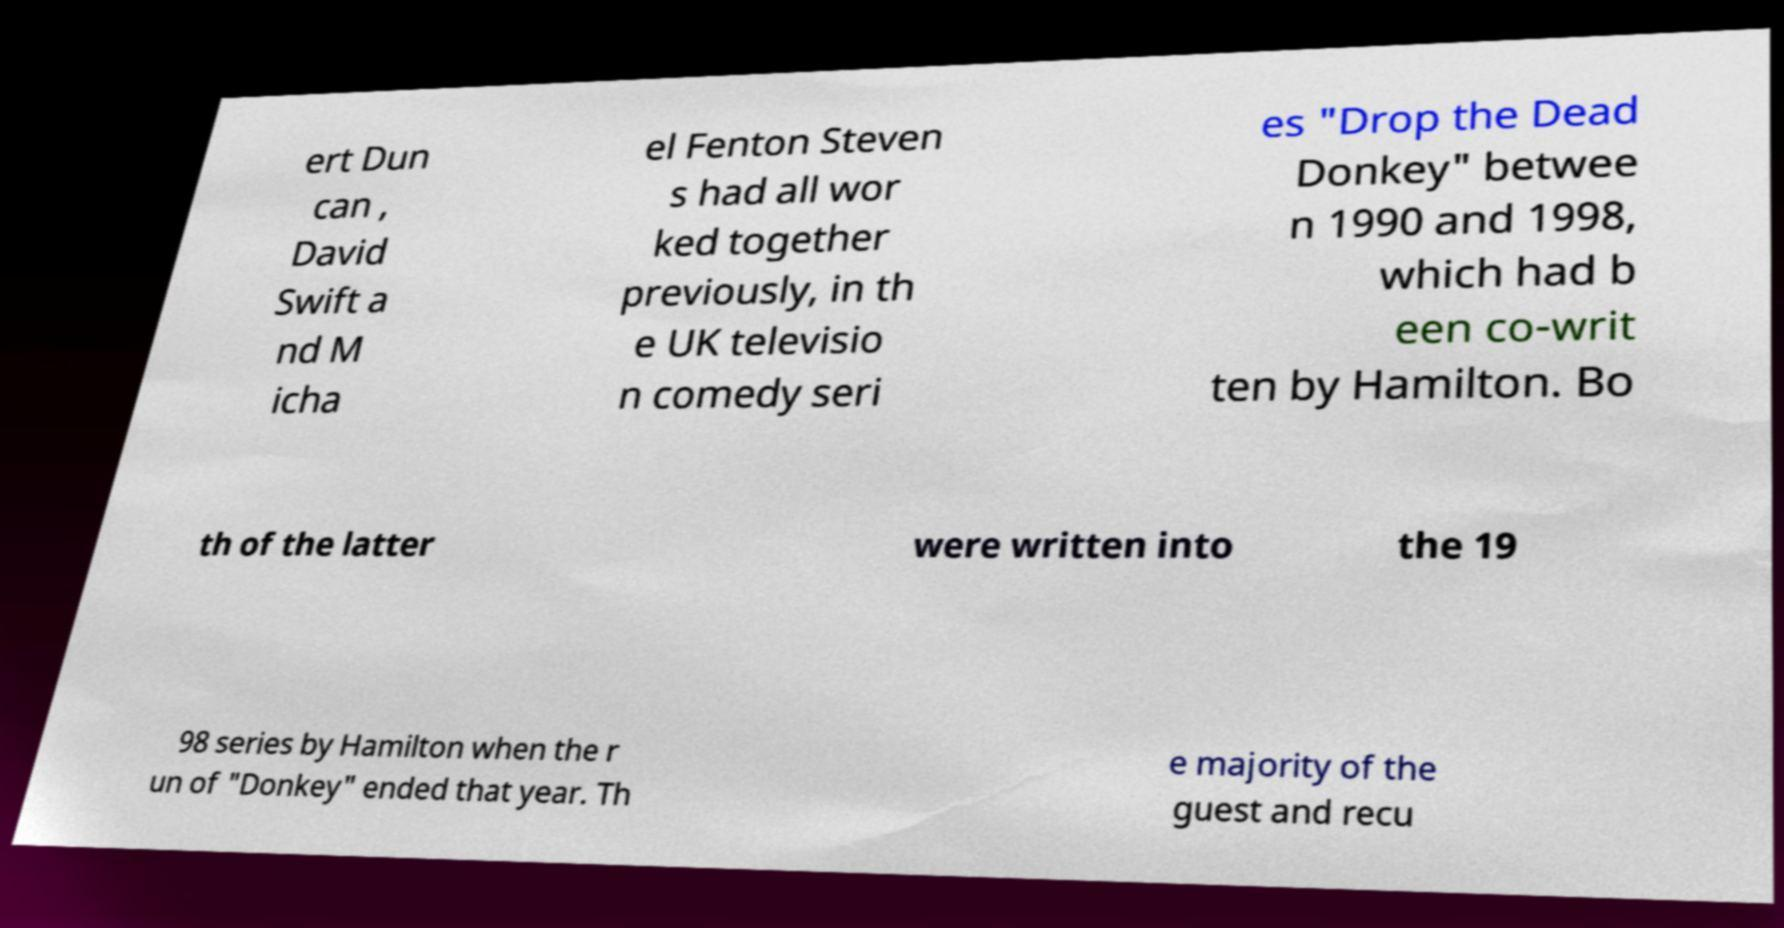Please read and relay the text visible in this image. What does it say? ert Dun can , David Swift a nd M icha el Fenton Steven s had all wor ked together previously, in th e UK televisio n comedy seri es "Drop the Dead Donkey" betwee n 1990 and 1998, which had b een co-writ ten by Hamilton. Bo th of the latter were written into the 19 98 series by Hamilton when the r un of "Donkey" ended that year. Th e majority of the guest and recu 